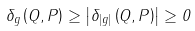<formula> <loc_0><loc_0><loc_500><loc_500>\delta _ { g } \left ( Q , P \right ) \geq \left | \delta _ { \left | g \right | } \left ( Q , P \right ) \right | \geq 0</formula> 